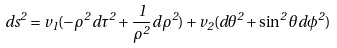Convert formula to latex. <formula><loc_0><loc_0><loc_500><loc_500>d s ^ { 2 } = v _ { 1 } ( - \rho ^ { 2 } d \tau ^ { 2 } + \frac { 1 } { \rho ^ { 2 } } d \rho ^ { 2 } ) + v _ { 2 } ( d \theta ^ { 2 } + \sin ^ { 2 } \theta d \phi ^ { 2 } )</formula> 